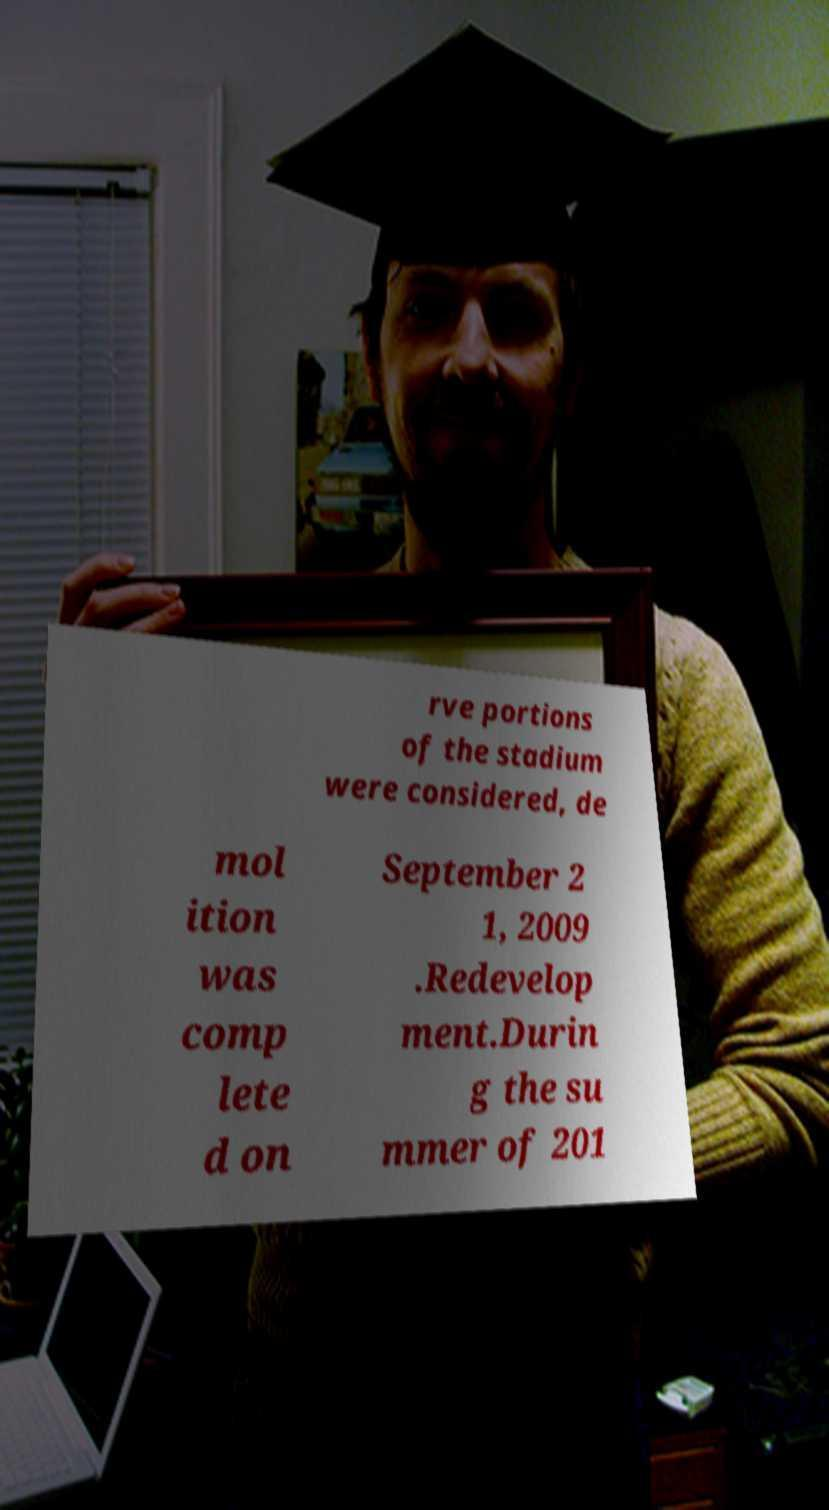Please read and relay the text visible in this image. What does it say? rve portions of the stadium were considered, de mol ition was comp lete d on September 2 1, 2009 .Redevelop ment.Durin g the su mmer of 201 